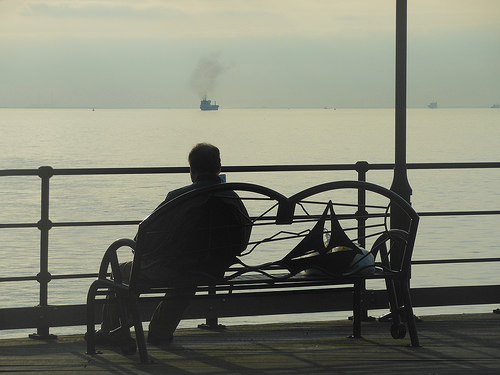<image>
Can you confirm if the ship is in the men? No. The ship is not contained within the men. These objects have a different spatial relationship. 